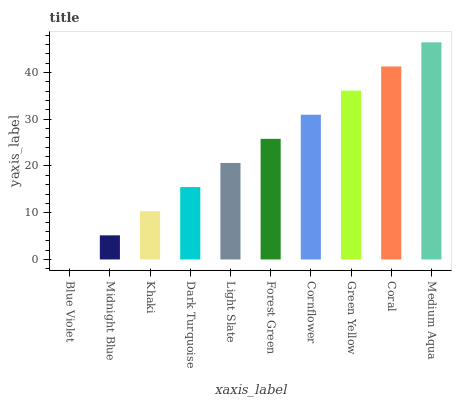Is Blue Violet the minimum?
Answer yes or no. Yes. Is Medium Aqua the maximum?
Answer yes or no. Yes. Is Midnight Blue the minimum?
Answer yes or no. No. Is Midnight Blue the maximum?
Answer yes or no. No. Is Midnight Blue greater than Blue Violet?
Answer yes or no. Yes. Is Blue Violet less than Midnight Blue?
Answer yes or no. Yes. Is Blue Violet greater than Midnight Blue?
Answer yes or no. No. Is Midnight Blue less than Blue Violet?
Answer yes or no. No. Is Forest Green the high median?
Answer yes or no. Yes. Is Light Slate the low median?
Answer yes or no. Yes. Is Medium Aqua the high median?
Answer yes or no. No. Is Khaki the low median?
Answer yes or no. No. 